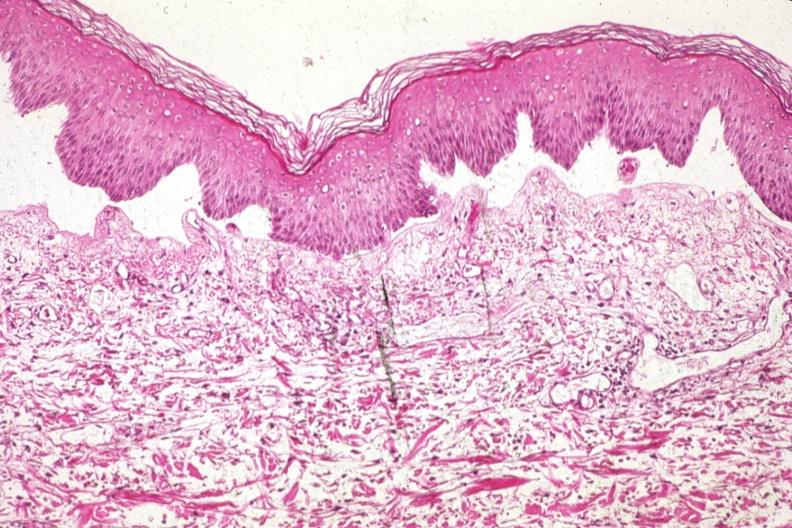what is 907?
Answer the question using a single word or phrase. Med excellent example of epidermal separation gross of this lesion 